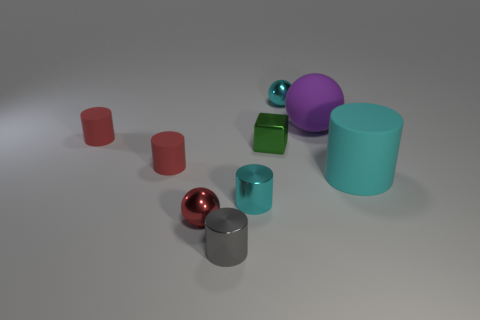Subtract all gray cylinders. How many cylinders are left? 4 Subtract all small metal cylinders. How many cylinders are left? 3 Subtract 2 cylinders. How many cylinders are left? 3 Subtract all purple cylinders. Subtract all red balls. How many cylinders are left? 5 Add 1 cylinders. How many objects exist? 10 Subtract all cylinders. How many objects are left? 4 Add 5 gray things. How many gray things are left? 6 Add 9 large red metal balls. How many large red metal balls exist? 9 Subtract 0 brown spheres. How many objects are left? 9 Subtract all tiny red matte spheres. Subtract all cyan rubber cylinders. How many objects are left? 8 